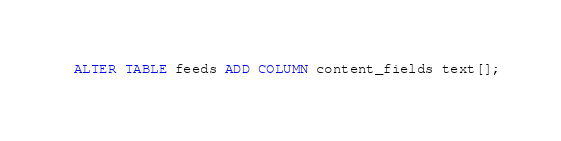<code> <loc_0><loc_0><loc_500><loc_500><_SQL_>ALTER TABLE feeds ADD COLUMN content_fields text[];
</code> 